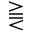Convert formula to latex. <formula><loc_0><loc_0><loc_500><loc_500>\gtreqqless</formula> 